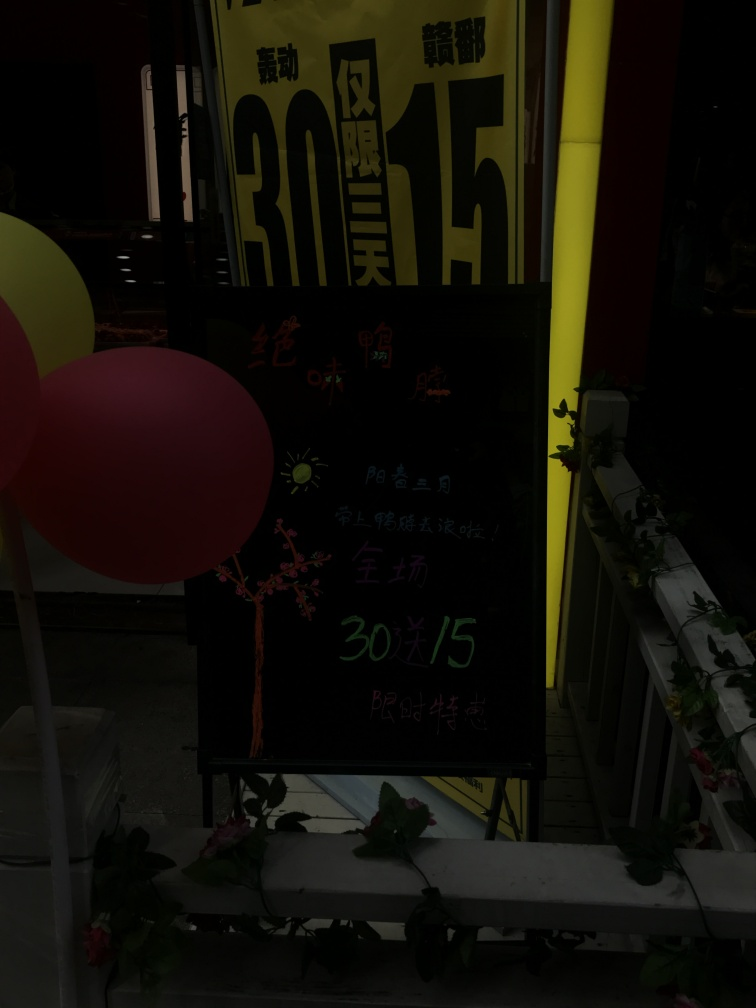Could you describe the mood or atmosphere this image conveys? The image conveys a somewhat mysterious and subdued atmosphere due to its dark tones and sparse lighting. The bright yellow sign offers a contrast which draws attention, while the rest of the photo's elements blend into shadows, suggesting an evening or nocturnal setting. It's a setting that could evoke curiosity about the activities taking place in this space. 